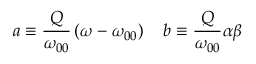<formula> <loc_0><loc_0><loc_500><loc_500>a \equiv \frac { Q } { \omega _ { 0 0 } } \left ( \omega - \omega _ { 0 0 } \right ) \quad b \equiv \frac { Q } { \omega _ { 0 0 } } \alpha \beta</formula> 